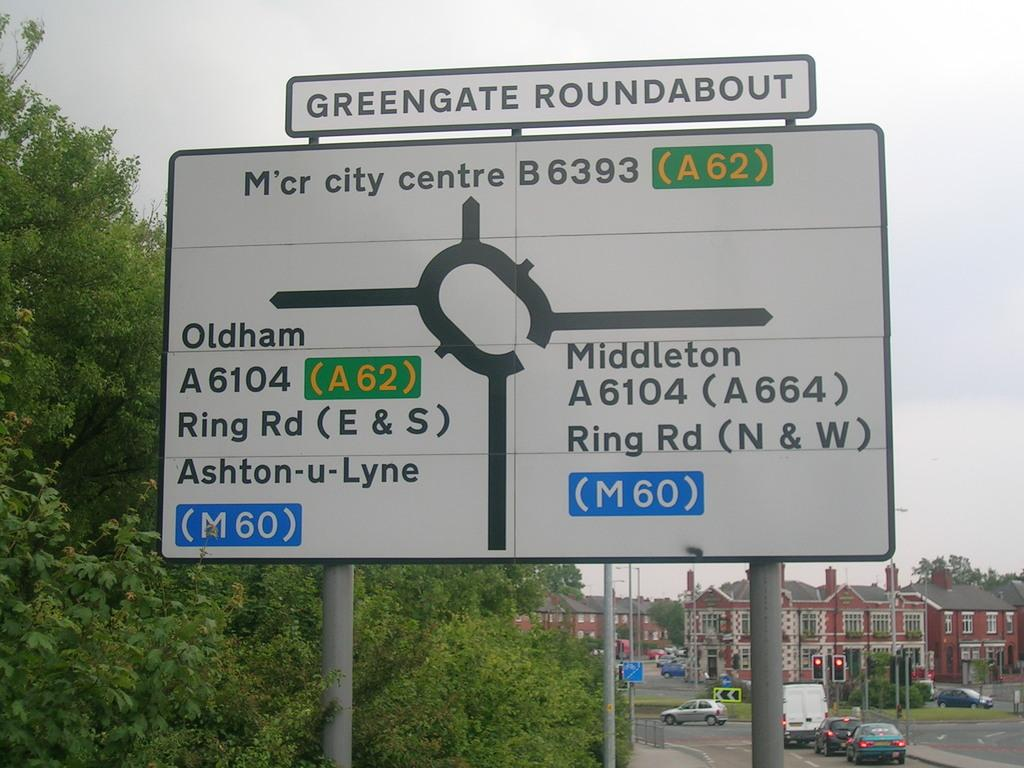<image>
Present a compact description of the photo's key features. A street sign shows the exits off of the Greengate Roundabout. 